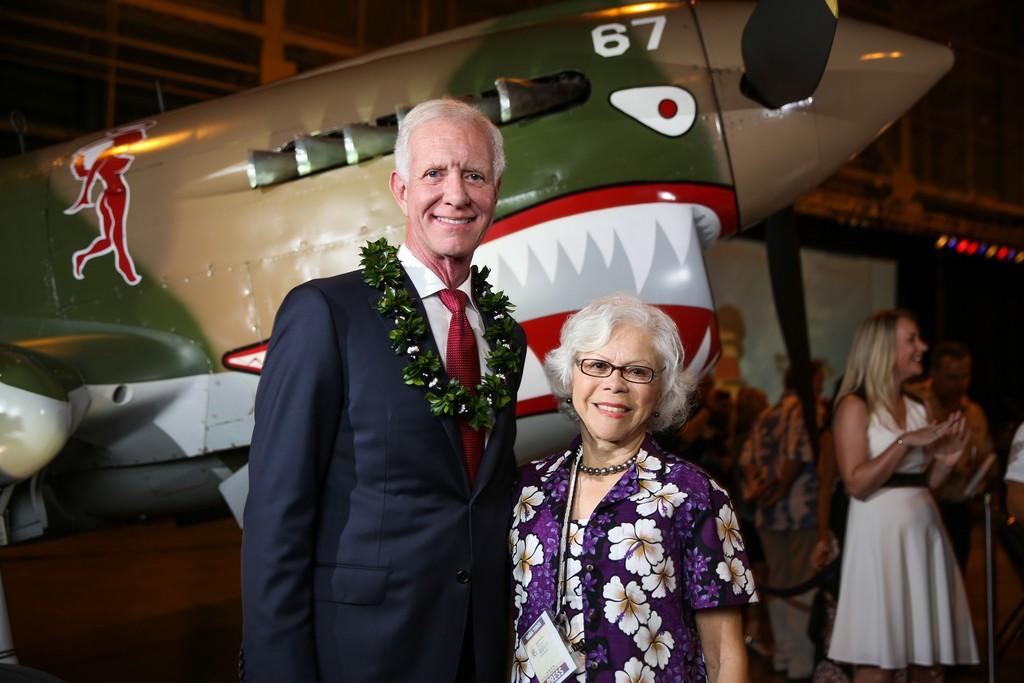<image>
Present a compact description of the photo's key features. Man and woman getting a picture taken at an event with a # 67 airplane. 